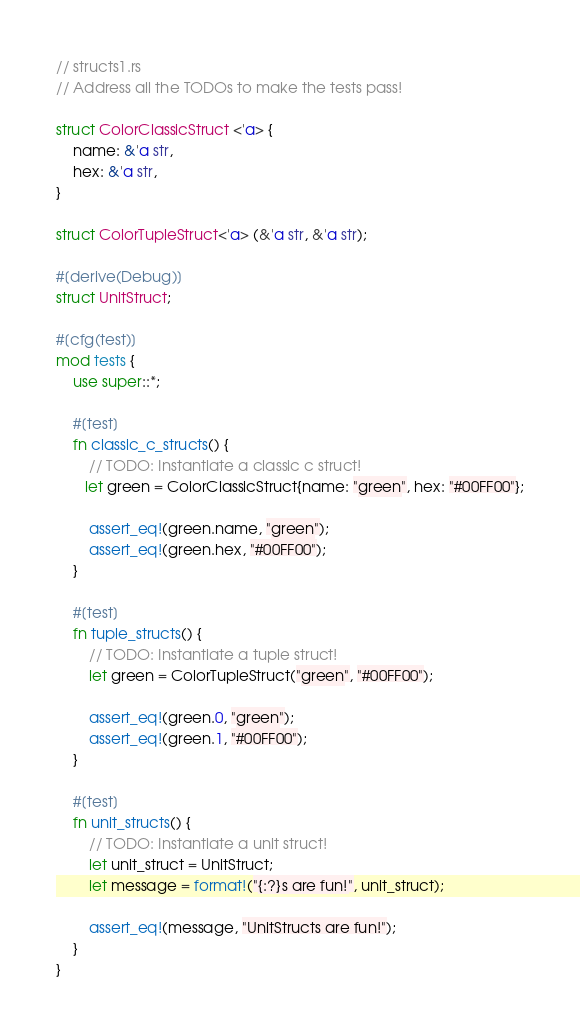<code> <loc_0><loc_0><loc_500><loc_500><_Rust_>// structs1.rs
// Address all the TODOs to make the tests pass!

struct ColorClassicStruct <'a> {
    name: &'a str,
    hex: &'a str,
}

struct ColorTupleStruct<'a> (&'a str, &'a str);

#[derive(Debug)]
struct UnitStruct;

#[cfg(test)]
mod tests {
    use super::*;

    #[test]
    fn classic_c_structs() {
        // TODO: Instantiate a classic c struct!
       let green = ColorClassicStruct{name: "green", hex: "#00FF00"};

        assert_eq!(green.name, "green");
        assert_eq!(green.hex, "#00FF00");
    }

    #[test]
    fn tuple_structs() {
        // TODO: Instantiate a tuple struct!
        let green = ColorTupleStruct("green", "#00FF00");

        assert_eq!(green.0, "green");
        assert_eq!(green.1, "#00FF00");
    }

    #[test]
    fn unit_structs() {
        // TODO: Instantiate a unit struct!
        let unit_struct = UnitStruct;
        let message = format!("{:?}s are fun!", unit_struct);

        assert_eq!(message, "UnitStructs are fun!");
    }
}
</code> 